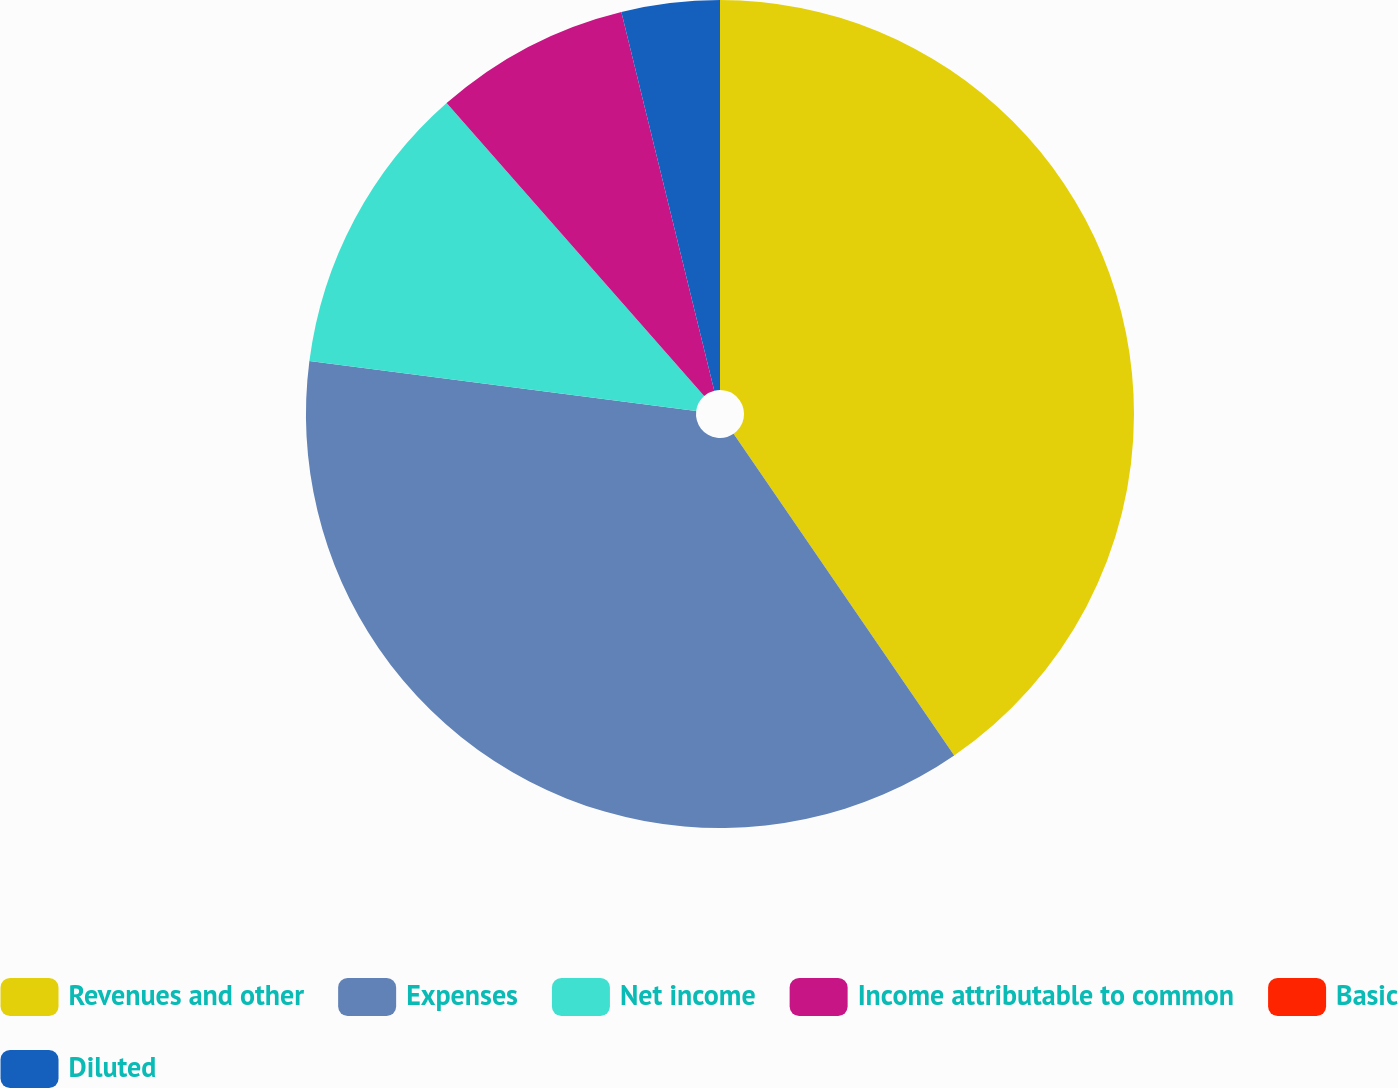Convert chart. <chart><loc_0><loc_0><loc_500><loc_500><pie_chart><fcel>Revenues and other<fcel>Expenses<fcel>Net income<fcel>Income attributable to common<fcel>Basic<fcel>Diluted<nl><fcel>40.43%<fcel>36.61%<fcel>11.48%<fcel>7.65%<fcel>0.0%<fcel>3.83%<nl></chart> 